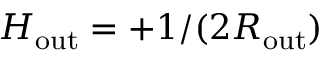Convert formula to latex. <formula><loc_0><loc_0><loc_500><loc_500>H _ { o u t } = + 1 / ( 2 R _ { o u t } )</formula> 